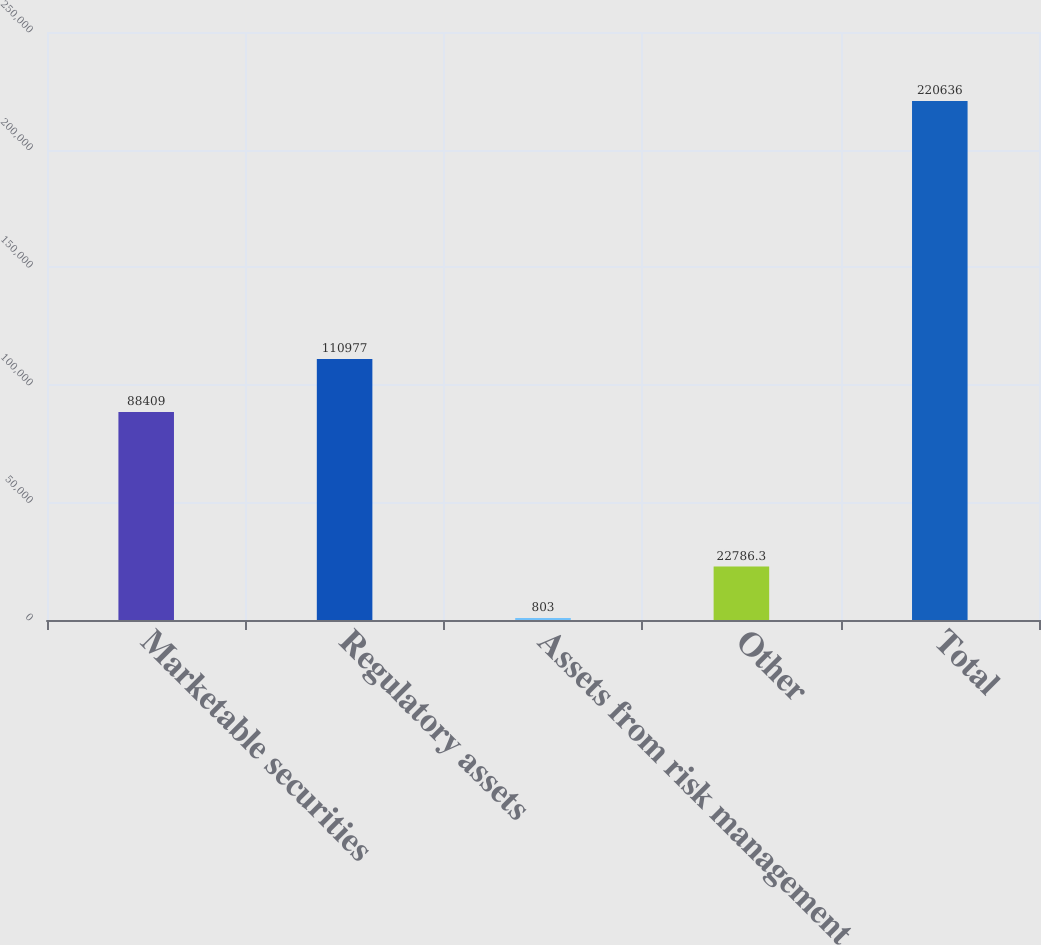<chart> <loc_0><loc_0><loc_500><loc_500><bar_chart><fcel>Marketable securities<fcel>Regulatory assets<fcel>Assets from risk management<fcel>Other<fcel>Total<nl><fcel>88409<fcel>110977<fcel>803<fcel>22786.3<fcel>220636<nl></chart> 